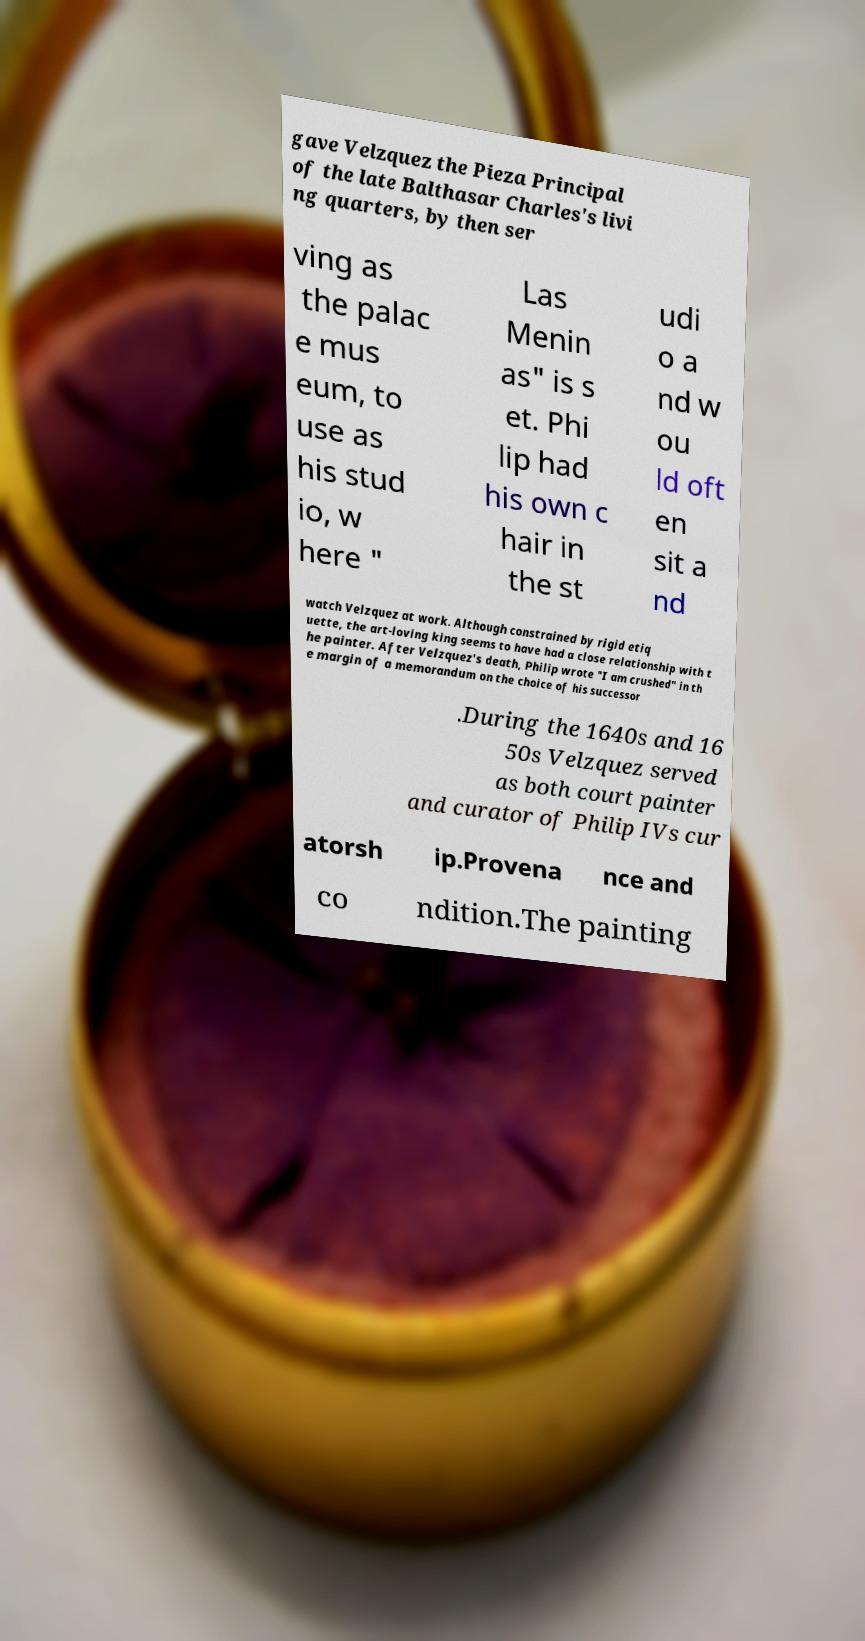Could you extract and type out the text from this image? gave Velzquez the Pieza Principal of the late Balthasar Charles's livi ng quarters, by then ser ving as the palac e mus eum, to use as his stud io, w here " Las Menin as" is s et. Phi lip had his own c hair in the st udi o a nd w ou ld oft en sit a nd watch Velzquez at work. Although constrained by rigid etiq uette, the art-loving king seems to have had a close relationship with t he painter. After Velzquez's death, Philip wrote "I am crushed" in th e margin of a memorandum on the choice of his successor .During the 1640s and 16 50s Velzquez served as both court painter and curator of Philip IVs cur atorsh ip.Provena nce and co ndition.The painting 